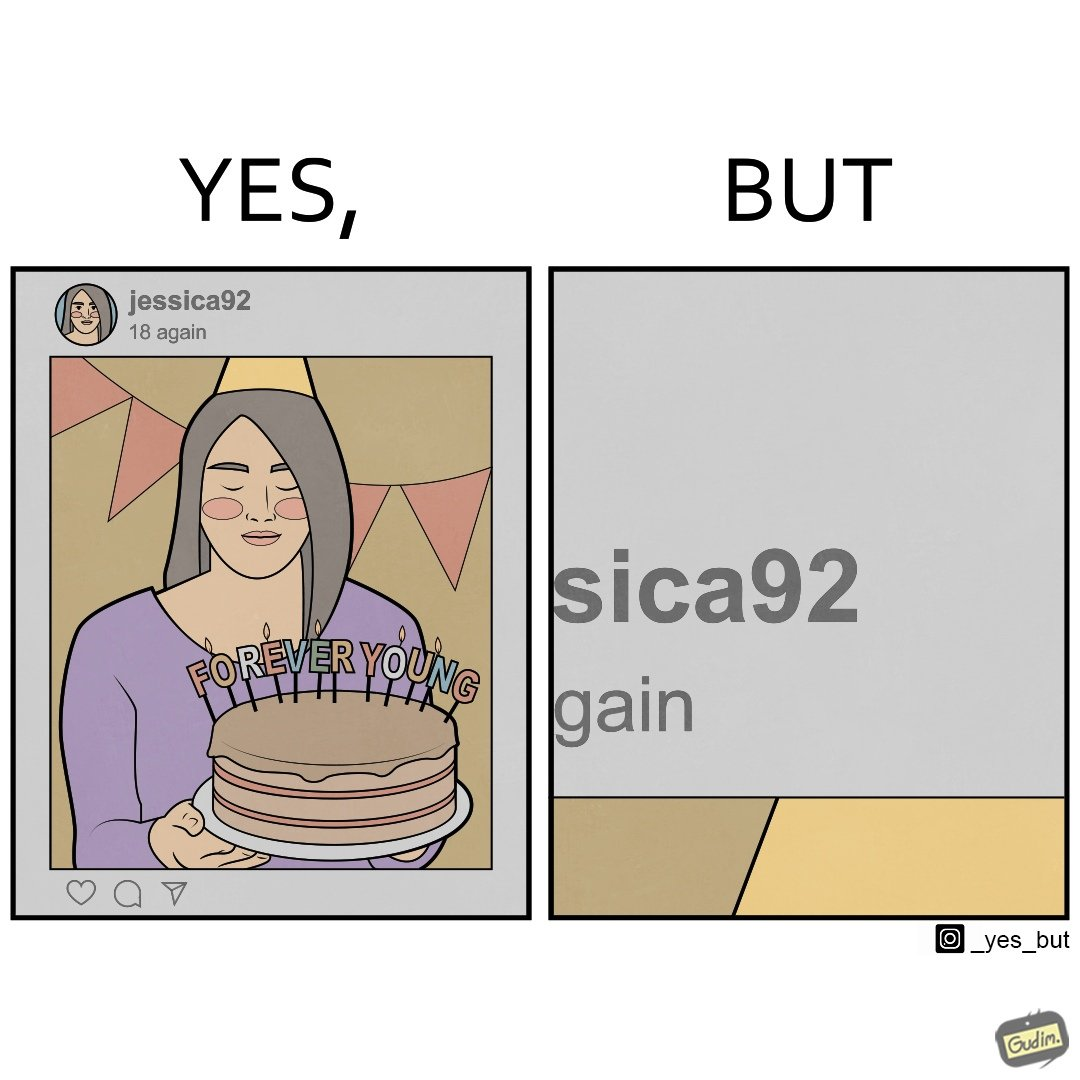Describe the contrast between the left and right parts of this image. In the left part of the image: The image shows a photo of a woman shared on an instagram like social media platform. The handle name of the profile that has shared the photo is "jessica92" and the text below her handle says "18 again". In the shared photo is a woman celebrating her birthday. She is holding a cake with lit candles saying "Forever Young". She is also wearing a celebration cone on her head. In the right part of the image: The image shows texts "sica92" and "gain" with the former above the latter. 